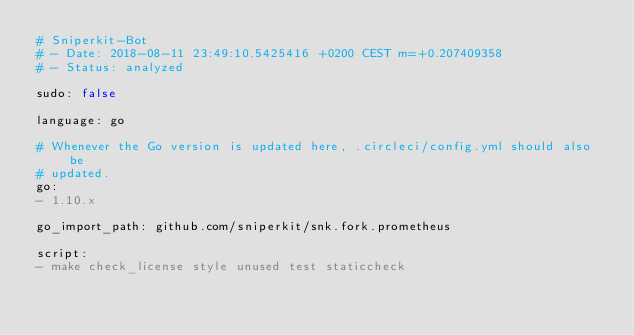<code> <loc_0><loc_0><loc_500><loc_500><_YAML_># Sniperkit-Bot
# - Date: 2018-08-11 23:49:10.5425416 +0200 CEST m=+0.207409358
# - Status: analyzed

sudo: false

language: go

# Whenever the Go version is updated here, .circleci/config.yml should also be
# updated.
go:
- 1.10.x

go_import_path: github.com/sniperkit/snk.fork.prometheus

script:
- make check_license style unused test staticcheck
</code> 